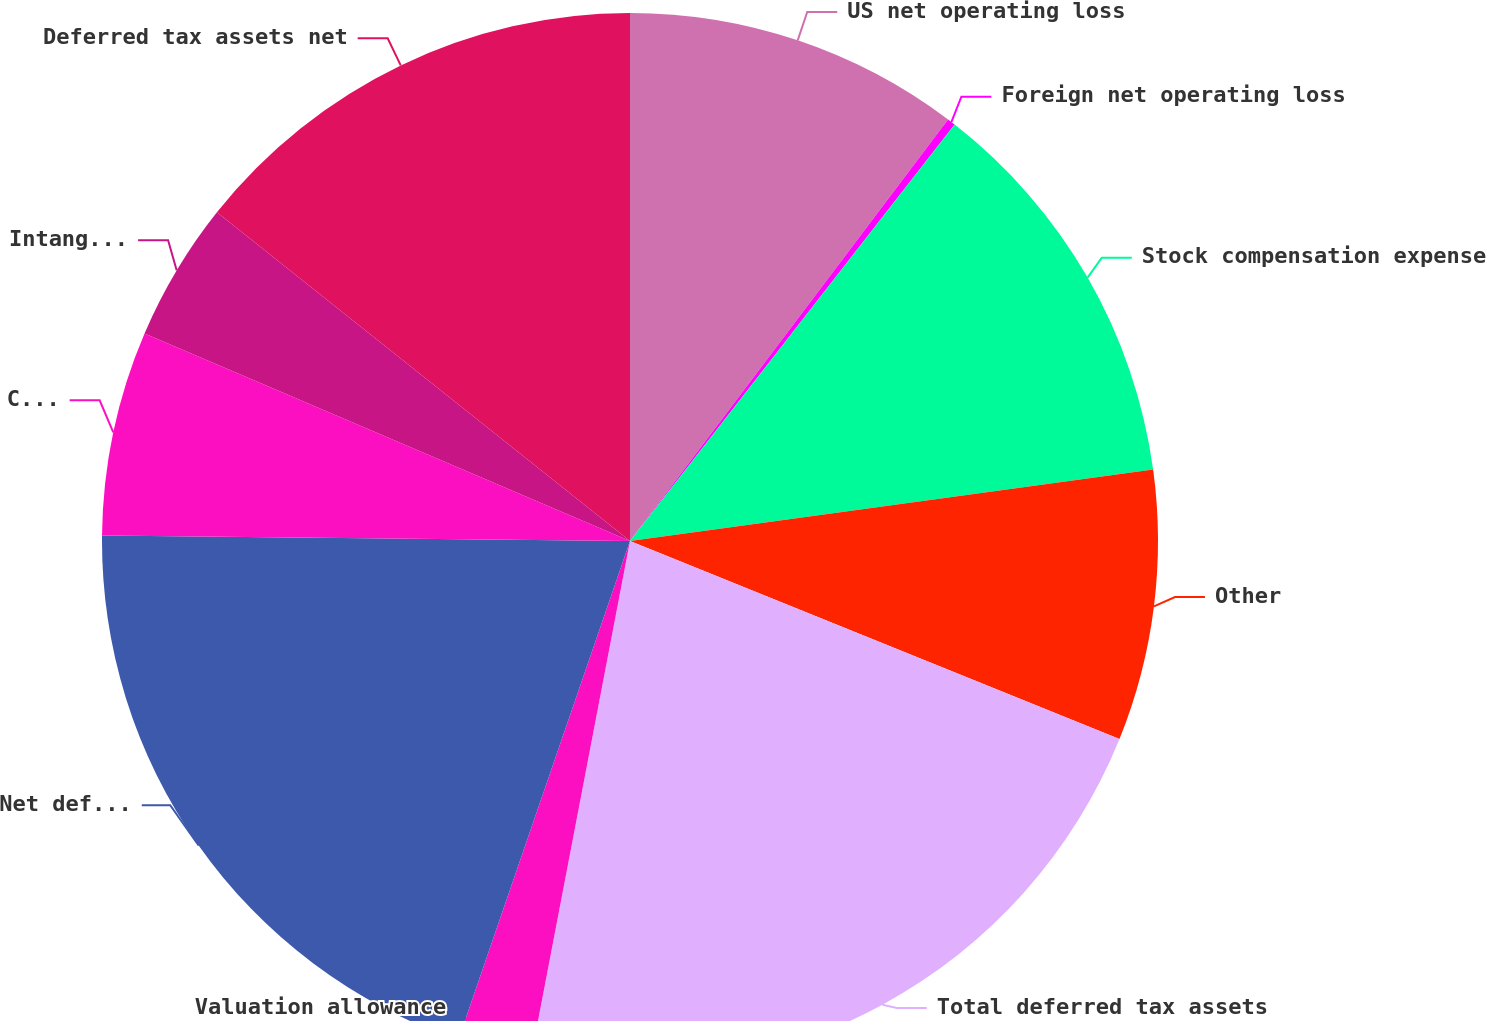Convert chart to OTSL. <chart><loc_0><loc_0><loc_500><loc_500><pie_chart><fcel>US net operating loss<fcel>Foreign net operating loss<fcel>Stock compensation expense<fcel>Other<fcel>Total deferred tax assets<fcel>Valuation allowance<fcel>Net deferred tax assets<fcel>Capitalized software<fcel>Intangible assets<fcel>Deferred tax assets net<nl><fcel>10.29%<fcel>0.25%<fcel>12.3%<fcel>8.28%<fcel>21.9%<fcel>2.26%<fcel>19.89%<fcel>6.27%<fcel>4.27%<fcel>14.3%<nl></chart> 